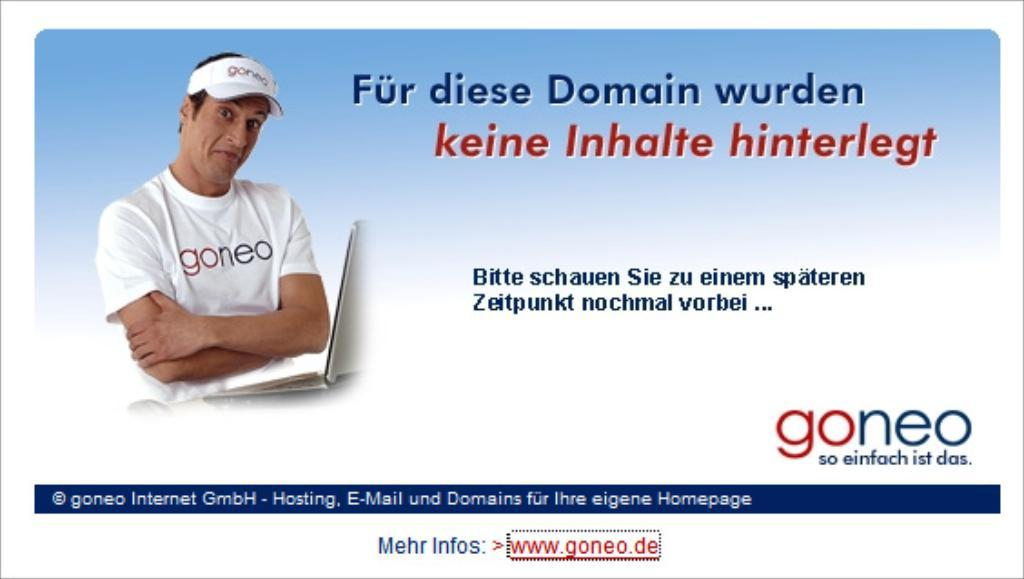What is the main subject of the image? The main subject of the image is a screenshot. What can be seen in the screenshot? The screenshot shows a person wearing a white dress and a cap. Is there any text or writing visible in the screenshot? Yes, there is text or writing visible on the screenshot. What is the cause of the army's decision in the image? There is no army or decision present in the image; it only shows a screenshot of a person wearing a white dress and a cap with text or writing. 